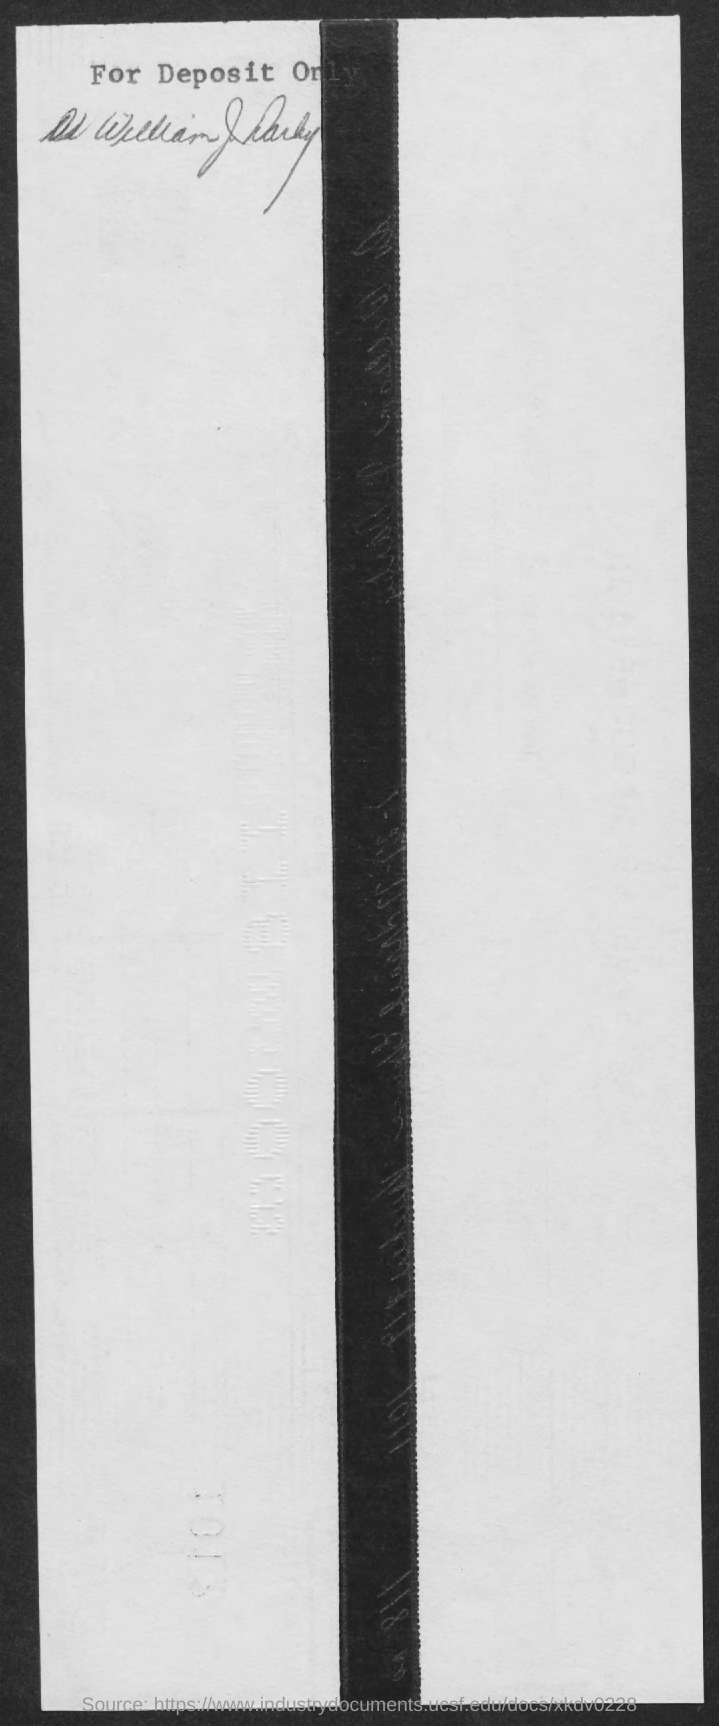Point out several critical features in this image. The first title in the document is 'For deposit only.' 